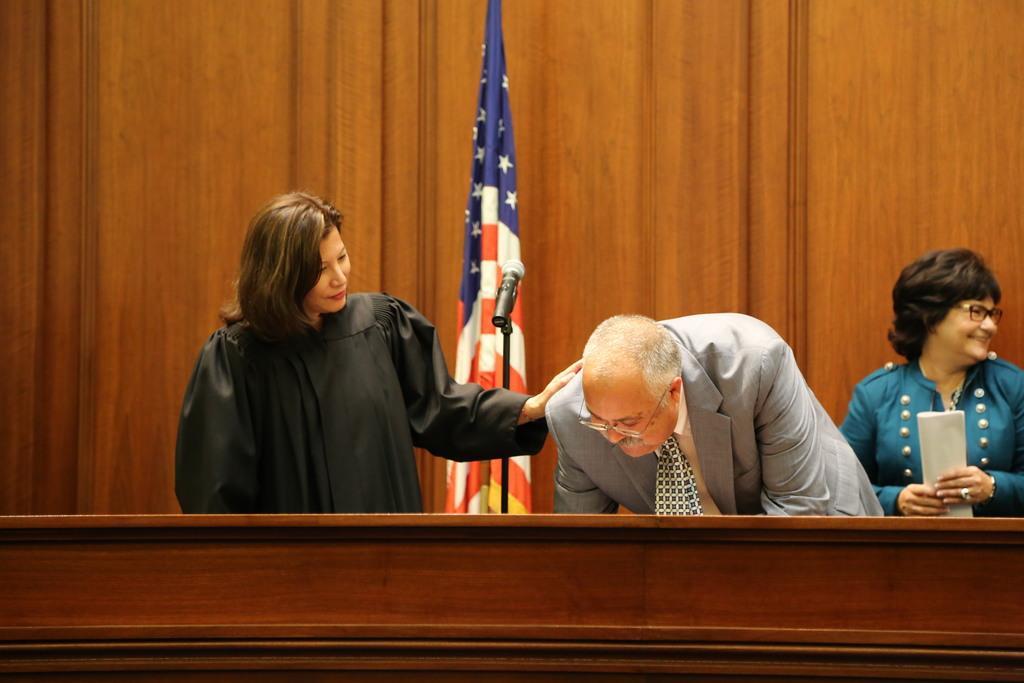Can you describe this image briefly? In this picture we can see three people, mic, flag, wooden objects and a woman wore spectacles, holding a paper with her hands and smiling. 